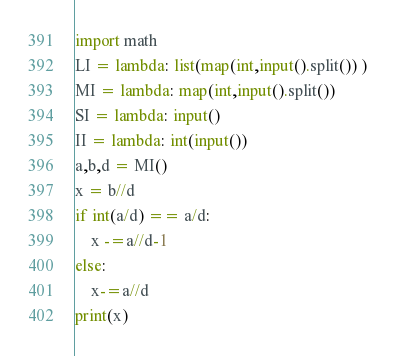Convert code to text. <code><loc_0><loc_0><loc_500><loc_500><_Python_>import math
LI = lambda: list(map(int,input().split()) )
MI = lambda: map(int,input().split())
SI = lambda: input()
II = lambda: int(input())
a,b,d = MI()
x = b//d
if int(a/d) == a/d:
    x -=a//d-1
else:
    x-=a//d
print(x)</code> 